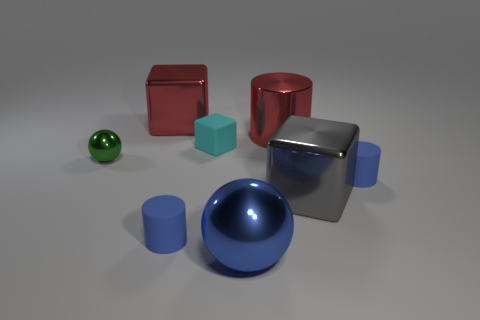There is a shiny cylinder; does it have the same color as the large thing left of the cyan matte thing?
Ensure brevity in your answer.  Yes. Is the number of big blue balls on the right side of the blue sphere less than the number of green rubber cylinders?
Your answer should be compact. No. What number of tiny yellow things are there?
Make the answer very short. 0. There is a matte thing that is behind the ball that is on the left side of the large blue thing; what shape is it?
Ensure brevity in your answer.  Cube. What number of large blue balls are left of the green shiny thing?
Your response must be concise. 0. Is the material of the small cyan thing the same as the small blue cylinder that is right of the red cylinder?
Give a very brief answer. Yes. Is there a rubber thing that has the same size as the green sphere?
Your answer should be very brief. Yes. Are there an equal number of cyan rubber cubes that are to the left of the tiny ball and large yellow metallic cylinders?
Offer a very short reply. Yes. The red cylinder has what size?
Make the answer very short. Large. What number of small blue rubber things are on the left side of the gray object that is behind the large ball?
Keep it short and to the point. 1. 